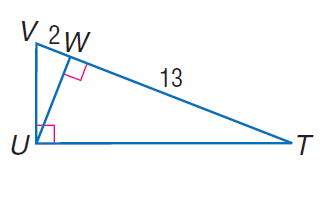Question: Find the measure of the altitude drawn to the hypotenuse.
Choices:
A. \sqrt { 2 }
B. \sqrt { 6.5 }
C. \sqrt { 13 }
D. \sqrt { 26 }
Answer with the letter. Answer: D 